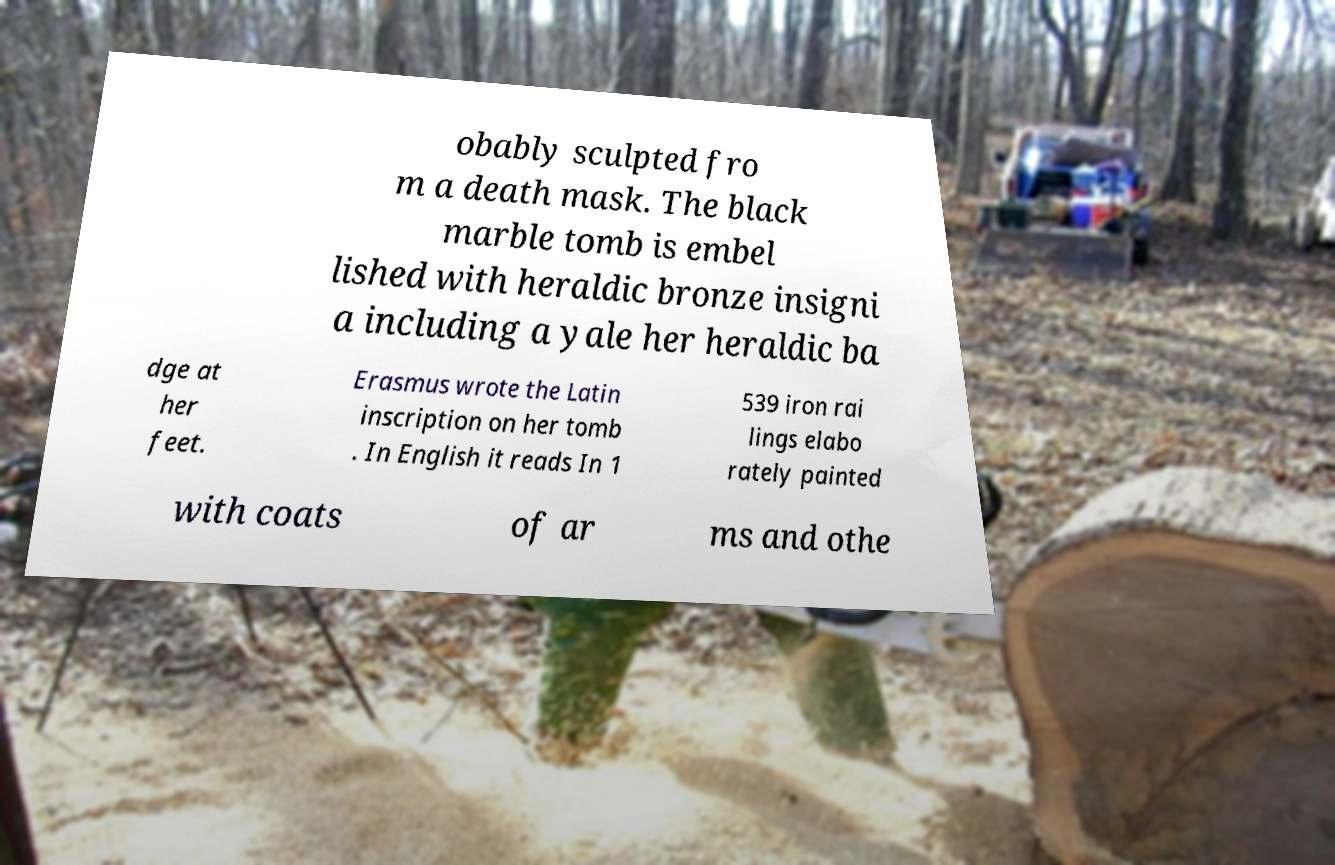Can you read and provide the text displayed in the image?This photo seems to have some interesting text. Can you extract and type it out for me? obably sculpted fro m a death mask. The black marble tomb is embel lished with heraldic bronze insigni a including a yale her heraldic ba dge at her feet. Erasmus wrote the Latin inscription on her tomb . In English it reads In 1 539 iron rai lings elabo rately painted with coats of ar ms and othe 